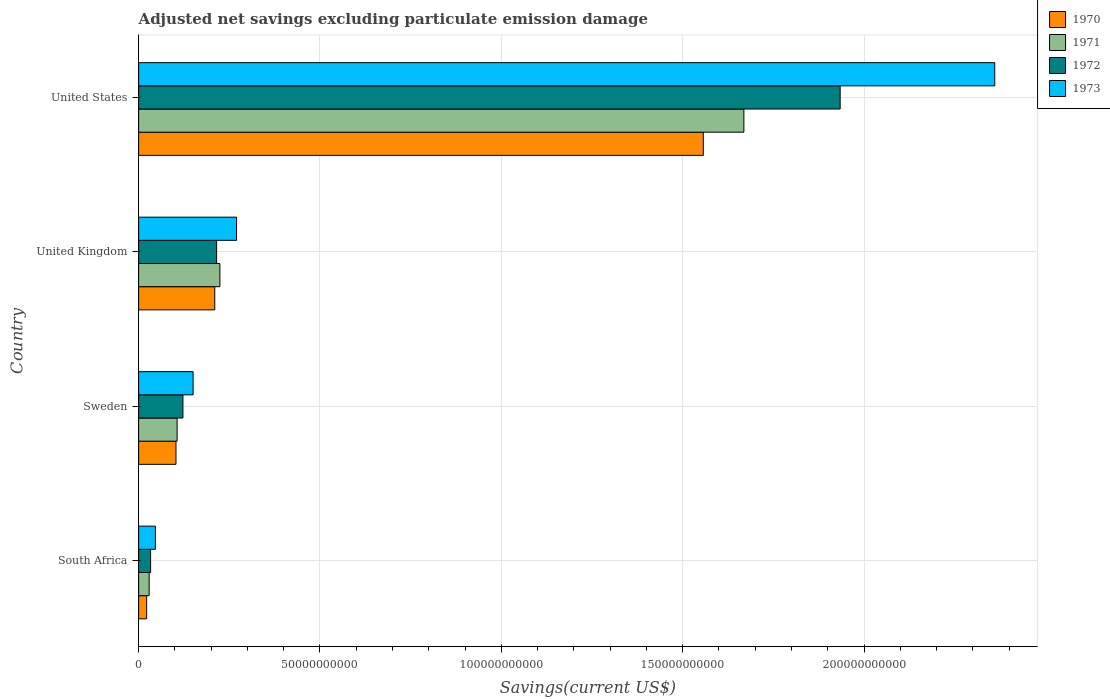How many groups of bars are there?
Offer a very short reply. 4. Are the number of bars per tick equal to the number of legend labels?
Ensure brevity in your answer.  Yes. What is the label of the 4th group of bars from the top?
Your answer should be compact. South Africa. In how many cases, is the number of bars for a given country not equal to the number of legend labels?
Your response must be concise. 0. What is the adjusted net savings in 1972 in Sweden?
Make the answer very short. 1.22e+1. Across all countries, what is the maximum adjusted net savings in 1972?
Your answer should be very brief. 1.93e+11. Across all countries, what is the minimum adjusted net savings in 1973?
Your answer should be compact. 4.62e+09. In which country was the adjusted net savings in 1973 minimum?
Your answer should be very brief. South Africa. What is the total adjusted net savings in 1970 in the graph?
Make the answer very short. 1.89e+11. What is the difference between the adjusted net savings in 1973 in South Africa and that in United States?
Provide a short and direct response. -2.31e+11. What is the difference between the adjusted net savings in 1973 in United States and the adjusted net savings in 1971 in United Kingdom?
Offer a terse response. 2.14e+11. What is the average adjusted net savings in 1973 per country?
Ensure brevity in your answer.  7.07e+1. What is the difference between the adjusted net savings in 1971 and adjusted net savings in 1973 in United States?
Keep it short and to the point. -6.92e+1. In how many countries, is the adjusted net savings in 1971 greater than 90000000000 US$?
Keep it short and to the point. 1. What is the ratio of the adjusted net savings in 1972 in South Africa to that in United Kingdom?
Keep it short and to the point. 0.15. Is the adjusted net savings in 1971 in South Africa less than that in United States?
Make the answer very short. Yes. What is the difference between the highest and the second highest adjusted net savings in 1972?
Ensure brevity in your answer.  1.72e+11. What is the difference between the highest and the lowest adjusted net savings in 1973?
Provide a short and direct response. 2.31e+11. In how many countries, is the adjusted net savings in 1970 greater than the average adjusted net savings in 1970 taken over all countries?
Give a very brief answer. 1. How many countries are there in the graph?
Provide a short and direct response. 4. What is the difference between two consecutive major ticks on the X-axis?
Ensure brevity in your answer.  5.00e+1. Does the graph contain grids?
Your answer should be compact. Yes. Where does the legend appear in the graph?
Your response must be concise. Top right. How many legend labels are there?
Your answer should be compact. 4. What is the title of the graph?
Provide a succinct answer. Adjusted net savings excluding particulate emission damage. Does "1987" appear as one of the legend labels in the graph?
Provide a succinct answer. No. What is the label or title of the X-axis?
Give a very brief answer. Savings(current US$). What is the label or title of the Y-axis?
Offer a terse response. Country. What is the Savings(current US$) in 1970 in South Africa?
Keep it short and to the point. 2.22e+09. What is the Savings(current US$) of 1971 in South Africa?
Ensure brevity in your answer.  2.90e+09. What is the Savings(current US$) of 1972 in South Africa?
Provide a succinct answer. 3.30e+09. What is the Savings(current US$) in 1973 in South Africa?
Your answer should be very brief. 4.62e+09. What is the Savings(current US$) in 1970 in Sweden?
Provide a succinct answer. 1.03e+1. What is the Savings(current US$) in 1971 in Sweden?
Offer a terse response. 1.06e+1. What is the Savings(current US$) in 1972 in Sweden?
Offer a very short reply. 1.22e+1. What is the Savings(current US$) in 1973 in Sweden?
Your response must be concise. 1.50e+1. What is the Savings(current US$) in 1970 in United Kingdom?
Offer a very short reply. 2.10e+1. What is the Savings(current US$) of 1971 in United Kingdom?
Give a very brief answer. 2.24e+1. What is the Savings(current US$) in 1972 in United Kingdom?
Give a very brief answer. 2.15e+1. What is the Savings(current US$) in 1973 in United Kingdom?
Your answer should be compact. 2.70e+1. What is the Savings(current US$) in 1970 in United States?
Your response must be concise. 1.56e+11. What is the Savings(current US$) of 1971 in United States?
Provide a succinct answer. 1.67e+11. What is the Savings(current US$) in 1972 in United States?
Ensure brevity in your answer.  1.93e+11. What is the Savings(current US$) of 1973 in United States?
Keep it short and to the point. 2.36e+11. Across all countries, what is the maximum Savings(current US$) in 1970?
Ensure brevity in your answer.  1.56e+11. Across all countries, what is the maximum Savings(current US$) in 1971?
Make the answer very short. 1.67e+11. Across all countries, what is the maximum Savings(current US$) of 1972?
Offer a terse response. 1.93e+11. Across all countries, what is the maximum Savings(current US$) in 1973?
Your response must be concise. 2.36e+11. Across all countries, what is the minimum Savings(current US$) in 1970?
Give a very brief answer. 2.22e+09. Across all countries, what is the minimum Savings(current US$) in 1971?
Keep it short and to the point. 2.90e+09. Across all countries, what is the minimum Savings(current US$) in 1972?
Make the answer very short. 3.30e+09. Across all countries, what is the minimum Savings(current US$) in 1973?
Provide a short and direct response. 4.62e+09. What is the total Savings(current US$) of 1970 in the graph?
Keep it short and to the point. 1.89e+11. What is the total Savings(current US$) in 1971 in the graph?
Offer a very short reply. 2.03e+11. What is the total Savings(current US$) of 1972 in the graph?
Provide a succinct answer. 2.30e+11. What is the total Savings(current US$) in 1973 in the graph?
Keep it short and to the point. 2.83e+11. What is the difference between the Savings(current US$) of 1970 in South Africa and that in Sweden?
Offer a very short reply. -8.08e+09. What is the difference between the Savings(current US$) in 1971 in South Africa and that in Sweden?
Offer a terse response. -7.70e+09. What is the difference between the Savings(current US$) of 1972 in South Africa and that in Sweden?
Your response must be concise. -8.91e+09. What is the difference between the Savings(current US$) of 1973 in South Africa and that in Sweden?
Your answer should be compact. -1.04e+1. What is the difference between the Savings(current US$) in 1970 in South Africa and that in United Kingdom?
Give a very brief answer. -1.88e+1. What is the difference between the Savings(current US$) in 1971 in South Africa and that in United Kingdom?
Give a very brief answer. -1.95e+1. What is the difference between the Savings(current US$) of 1972 in South Africa and that in United Kingdom?
Give a very brief answer. -1.82e+1. What is the difference between the Savings(current US$) in 1973 in South Africa and that in United Kingdom?
Offer a very short reply. -2.24e+1. What is the difference between the Savings(current US$) of 1970 in South Africa and that in United States?
Give a very brief answer. -1.53e+11. What is the difference between the Savings(current US$) of 1971 in South Africa and that in United States?
Your answer should be very brief. -1.64e+11. What is the difference between the Savings(current US$) of 1972 in South Africa and that in United States?
Make the answer very short. -1.90e+11. What is the difference between the Savings(current US$) of 1973 in South Africa and that in United States?
Provide a succinct answer. -2.31e+11. What is the difference between the Savings(current US$) in 1970 in Sweden and that in United Kingdom?
Provide a succinct answer. -1.07e+1. What is the difference between the Savings(current US$) in 1971 in Sweden and that in United Kingdom?
Provide a short and direct response. -1.18e+1. What is the difference between the Savings(current US$) of 1972 in Sweden and that in United Kingdom?
Make the answer very short. -9.28e+09. What is the difference between the Savings(current US$) in 1973 in Sweden and that in United Kingdom?
Your answer should be very brief. -1.20e+1. What is the difference between the Savings(current US$) in 1970 in Sweden and that in United States?
Keep it short and to the point. -1.45e+11. What is the difference between the Savings(current US$) in 1971 in Sweden and that in United States?
Offer a terse response. -1.56e+11. What is the difference between the Savings(current US$) in 1972 in Sweden and that in United States?
Offer a terse response. -1.81e+11. What is the difference between the Savings(current US$) of 1973 in Sweden and that in United States?
Your answer should be compact. -2.21e+11. What is the difference between the Savings(current US$) in 1970 in United Kingdom and that in United States?
Your response must be concise. -1.35e+11. What is the difference between the Savings(current US$) of 1971 in United Kingdom and that in United States?
Your answer should be compact. -1.44e+11. What is the difference between the Savings(current US$) of 1972 in United Kingdom and that in United States?
Your answer should be compact. -1.72e+11. What is the difference between the Savings(current US$) in 1973 in United Kingdom and that in United States?
Make the answer very short. -2.09e+11. What is the difference between the Savings(current US$) in 1970 in South Africa and the Savings(current US$) in 1971 in Sweden?
Your answer should be compact. -8.39e+09. What is the difference between the Savings(current US$) in 1970 in South Africa and the Savings(current US$) in 1972 in Sweden?
Provide a short and direct response. -1.00e+1. What is the difference between the Savings(current US$) in 1970 in South Africa and the Savings(current US$) in 1973 in Sweden?
Offer a very short reply. -1.28e+1. What is the difference between the Savings(current US$) of 1971 in South Africa and the Savings(current US$) of 1972 in Sweden?
Your answer should be very brief. -9.31e+09. What is the difference between the Savings(current US$) of 1971 in South Africa and the Savings(current US$) of 1973 in Sweden?
Your response must be concise. -1.21e+1. What is the difference between the Savings(current US$) of 1972 in South Africa and the Savings(current US$) of 1973 in Sweden?
Your answer should be compact. -1.17e+1. What is the difference between the Savings(current US$) of 1970 in South Africa and the Savings(current US$) of 1971 in United Kingdom?
Your answer should be very brief. -2.02e+1. What is the difference between the Savings(current US$) in 1970 in South Africa and the Savings(current US$) in 1972 in United Kingdom?
Give a very brief answer. -1.93e+1. What is the difference between the Savings(current US$) of 1970 in South Africa and the Savings(current US$) of 1973 in United Kingdom?
Make the answer very short. -2.48e+1. What is the difference between the Savings(current US$) in 1971 in South Africa and the Savings(current US$) in 1972 in United Kingdom?
Make the answer very short. -1.86e+1. What is the difference between the Savings(current US$) of 1971 in South Africa and the Savings(current US$) of 1973 in United Kingdom?
Make the answer very short. -2.41e+1. What is the difference between the Savings(current US$) in 1972 in South Africa and the Savings(current US$) in 1973 in United Kingdom?
Your response must be concise. -2.37e+1. What is the difference between the Savings(current US$) in 1970 in South Africa and the Savings(current US$) in 1971 in United States?
Give a very brief answer. -1.65e+11. What is the difference between the Savings(current US$) of 1970 in South Africa and the Savings(current US$) of 1972 in United States?
Your response must be concise. -1.91e+11. What is the difference between the Savings(current US$) of 1970 in South Africa and the Savings(current US$) of 1973 in United States?
Give a very brief answer. -2.34e+11. What is the difference between the Savings(current US$) in 1971 in South Africa and the Savings(current US$) in 1972 in United States?
Your answer should be compact. -1.91e+11. What is the difference between the Savings(current US$) of 1971 in South Africa and the Savings(current US$) of 1973 in United States?
Offer a terse response. -2.33e+11. What is the difference between the Savings(current US$) in 1972 in South Africa and the Savings(current US$) in 1973 in United States?
Your response must be concise. -2.33e+11. What is the difference between the Savings(current US$) in 1970 in Sweden and the Savings(current US$) in 1971 in United Kingdom?
Ensure brevity in your answer.  -1.21e+1. What is the difference between the Savings(current US$) in 1970 in Sweden and the Savings(current US$) in 1972 in United Kingdom?
Offer a very short reply. -1.12e+1. What is the difference between the Savings(current US$) in 1970 in Sweden and the Savings(current US$) in 1973 in United Kingdom?
Offer a very short reply. -1.67e+1. What is the difference between the Savings(current US$) in 1971 in Sweden and the Savings(current US$) in 1972 in United Kingdom?
Ensure brevity in your answer.  -1.09e+1. What is the difference between the Savings(current US$) of 1971 in Sweden and the Savings(current US$) of 1973 in United Kingdom?
Provide a succinct answer. -1.64e+1. What is the difference between the Savings(current US$) of 1972 in Sweden and the Savings(current US$) of 1973 in United Kingdom?
Offer a very short reply. -1.48e+1. What is the difference between the Savings(current US$) in 1970 in Sweden and the Savings(current US$) in 1971 in United States?
Your answer should be very brief. -1.57e+11. What is the difference between the Savings(current US$) in 1970 in Sweden and the Savings(current US$) in 1972 in United States?
Make the answer very short. -1.83e+11. What is the difference between the Savings(current US$) in 1970 in Sweden and the Savings(current US$) in 1973 in United States?
Provide a succinct answer. -2.26e+11. What is the difference between the Savings(current US$) of 1971 in Sweden and the Savings(current US$) of 1972 in United States?
Offer a very short reply. -1.83e+11. What is the difference between the Savings(current US$) in 1971 in Sweden and the Savings(current US$) in 1973 in United States?
Keep it short and to the point. -2.25e+11. What is the difference between the Savings(current US$) of 1972 in Sweden and the Savings(current US$) of 1973 in United States?
Make the answer very short. -2.24e+11. What is the difference between the Savings(current US$) in 1970 in United Kingdom and the Savings(current US$) in 1971 in United States?
Your answer should be very brief. -1.46e+11. What is the difference between the Savings(current US$) of 1970 in United Kingdom and the Savings(current US$) of 1972 in United States?
Keep it short and to the point. -1.72e+11. What is the difference between the Savings(current US$) in 1970 in United Kingdom and the Savings(current US$) in 1973 in United States?
Ensure brevity in your answer.  -2.15e+11. What is the difference between the Savings(current US$) of 1971 in United Kingdom and the Savings(current US$) of 1972 in United States?
Keep it short and to the point. -1.71e+11. What is the difference between the Savings(current US$) in 1971 in United Kingdom and the Savings(current US$) in 1973 in United States?
Provide a succinct answer. -2.14e+11. What is the difference between the Savings(current US$) of 1972 in United Kingdom and the Savings(current US$) of 1973 in United States?
Give a very brief answer. -2.15e+11. What is the average Savings(current US$) of 1970 per country?
Make the answer very short. 4.73e+1. What is the average Savings(current US$) of 1971 per country?
Keep it short and to the point. 5.07e+1. What is the average Savings(current US$) in 1972 per country?
Your answer should be compact. 5.76e+1. What is the average Savings(current US$) in 1973 per country?
Provide a succinct answer. 7.07e+1. What is the difference between the Savings(current US$) of 1970 and Savings(current US$) of 1971 in South Africa?
Provide a short and direct response. -6.85e+08. What is the difference between the Savings(current US$) in 1970 and Savings(current US$) in 1972 in South Africa?
Keep it short and to the point. -1.08e+09. What is the difference between the Savings(current US$) of 1970 and Savings(current US$) of 1973 in South Africa?
Keep it short and to the point. -2.40e+09. What is the difference between the Savings(current US$) of 1971 and Savings(current US$) of 1972 in South Africa?
Your answer should be very brief. -4.00e+08. What is the difference between the Savings(current US$) of 1971 and Savings(current US$) of 1973 in South Africa?
Ensure brevity in your answer.  -1.72e+09. What is the difference between the Savings(current US$) in 1972 and Savings(current US$) in 1973 in South Africa?
Keep it short and to the point. -1.32e+09. What is the difference between the Savings(current US$) in 1970 and Savings(current US$) in 1971 in Sweden?
Give a very brief answer. -3.10e+08. What is the difference between the Savings(current US$) in 1970 and Savings(current US$) in 1972 in Sweden?
Keep it short and to the point. -1.92e+09. What is the difference between the Savings(current US$) of 1970 and Savings(current US$) of 1973 in Sweden?
Offer a terse response. -4.72e+09. What is the difference between the Savings(current US$) of 1971 and Savings(current US$) of 1972 in Sweden?
Provide a short and direct response. -1.61e+09. What is the difference between the Savings(current US$) in 1971 and Savings(current US$) in 1973 in Sweden?
Your answer should be very brief. -4.41e+09. What is the difference between the Savings(current US$) of 1972 and Savings(current US$) of 1973 in Sweden?
Offer a terse response. -2.80e+09. What is the difference between the Savings(current US$) of 1970 and Savings(current US$) of 1971 in United Kingdom?
Provide a succinct answer. -1.41e+09. What is the difference between the Savings(current US$) of 1970 and Savings(current US$) of 1972 in United Kingdom?
Provide a short and direct response. -5.08e+08. What is the difference between the Savings(current US$) of 1970 and Savings(current US$) of 1973 in United Kingdom?
Provide a succinct answer. -6.01e+09. What is the difference between the Savings(current US$) of 1971 and Savings(current US$) of 1972 in United Kingdom?
Your response must be concise. 9.03e+08. What is the difference between the Savings(current US$) of 1971 and Savings(current US$) of 1973 in United Kingdom?
Your response must be concise. -4.60e+09. What is the difference between the Savings(current US$) of 1972 and Savings(current US$) of 1973 in United Kingdom?
Offer a terse response. -5.50e+09. What is the difference between the Savings(current US$) of 1970 and Savings(current US$) of 1971 in United States?
Your answer should be very brief. -1.12e+1. What is the difference between the Savings(current US$) of 1970 and Savings(current US$) of 1972 in United States?
Your answer should be compact. -3.77e+1. What is the difference between the Savings(current US$) in 1970 and Savings(current US$) in 1973 in United States?
Your answer should be very brief. -8.03e+1. What is the difference between the Savings(current US$) of 1971 and Savings(current US$) of 1972 in United States?
Make the answer very short. -2.65e+1. What is the difference between the Savings(current US$) in 1971 and Savings(current US$) in 1973 in United States?
Give a very brief answer. -6.92e+1. What is the difference between the Savings(current US$) of 1972 and Savings(current US$) of 1973 in United States?
Provide a short and direct response. -4.26e+1. What is the ratio of the Savings(current US$) in 1970 in South Africa to that in Sweden?
Provide a short and direct response. 0.22. What is the ratio of the Savings(current US$) of 1971 in South Africa to that in Sweden?
Provide a succinct answer. 0.27. What is the ratio of the Savings(current US$) of 1972 in South Africa to that in Sweden?
Provide a succinct answer. 0.27. What is the ratio of the Savings(current US$) in 1973 in South Africa to that in Sweden?
Your response must be concise. 0.31. What is the ratio of the Savings(current US$) of 1970 in South Africa to that in United Kingdom?
Your answer should be very brief. 0.11. What is the ratio of the Savings(current US$) in 1971 in South Africa to that in United Kingdom?
Offer a very short reply. 0.13. What is the ratio of the Savings(current US$) of 1972 in South Africa to that in United Kingdom?
Offer a terse response. 0.15. What is the ratio of the Savings(current US$) of 1973 in South Africa to that in United Kingdom?
Ensure brevity in your answer.  0.17. What is the ratio of the Savings(current US$) in 1970 in South Africa to that in United States?
Give a very brief answer. 0.01. What is the ratio of the Savings(current US$) in 1971 in South Africa to that in United States?
Keep it short and to the point. 0.02. What is the ratio of the Savings(current US$) in 1972 in South Africa to that in United States?
Your answer should be compact. 0.02. What is the ratio of the Savings(current US$) of 1973 in South Africa to that in United States?
Provide a succinct answer. 0.02. What is the ratio of the Savings(current US$) in 1970 in Sweden to that in United Kingdom?
Ensure brevity in your answer.  0.49. What is the ratio of the Savings(current US$) in 1971 in Sweden to that in United Kingdom?
Ensure brevity in your answer.  0.47. What is the ratio of the Savings(current US$) of 1972 in Sweden to that in United Kingdom?
Provide a short and direct response. 0.57. What is the ratio of the Savings(current US$) of 1973 in Sweden to that in United Kingdom?
Offer a terse response. 0.56. What is the ratio of the Savings(current US$) of 1970 in Sweden to that in United States?
Make the answer very short. 0.07. What is the ratio of the Savings(current US$) in 1971 in Sweden to that in United States?
Your answer should be very brief. 0.06. What is the ratio of the Savings(current US$) of 1972 in Sweden to that in United States?
Offer a terse response. 0.06. What is the ratio of the Savings(current US$) in 1973 in Sweden to that in United States?
Provide a short and direct response. 0.06. What is the ratio of the Savings(current US$) of 1970 in United Kingdom to that in United States?
Your answer should be compact. 0.13. What is the ratio of the Savings(current US$) in 1971 in United Kingdom to that in United States?
Your answer should be compact. 0.13. What is the ratio of the Savings(current US$) in 1972 in United Kingdom to that in United States?
Your answer should be compact. 0.11. What is the ratio of the Savings(current US$) of 1973 in United Kingdom to that in United States?
Make the answer very short. 0.11. What is the difference between the highest and the second highest Savings(current US$) in 1970?
Give a very brief answer. 1.35e+11. What is the difference between the highest and the second highest Savings(current US$) of 1971?
Offer a very short reply. 1.44e+11. What is the difference between the highest and the second highest Savings(current US$) in 1972?
Keep it short and to the point. 1.72e+11. What is the difference between the highest and the second highest Savings(current US$) of 1973?
Your response must be concise. 2.09e+11. What is the difference between the highest and the lowest Savings(current US$) in 1970?
Give a very brief answer. 1.53e+11. What is the difference between the highest and the lowest Savings(current US$) of 1971?
Keep it short and to the point. 1.64e+11. What is the difference between the highest and the lowest Savings(current US$) in 1972?
Make the answer very short. 1.90e+11. What is the difference between the highest and the lowest Savings(current US$) of 1973?
Make the answer very short. 2.31e+11. 